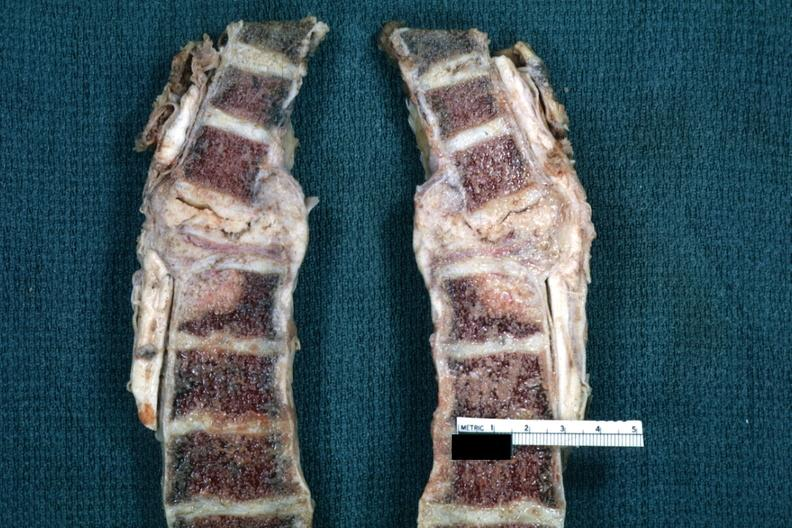s joints present?
Answer the question using a single word or phrase. Yes 